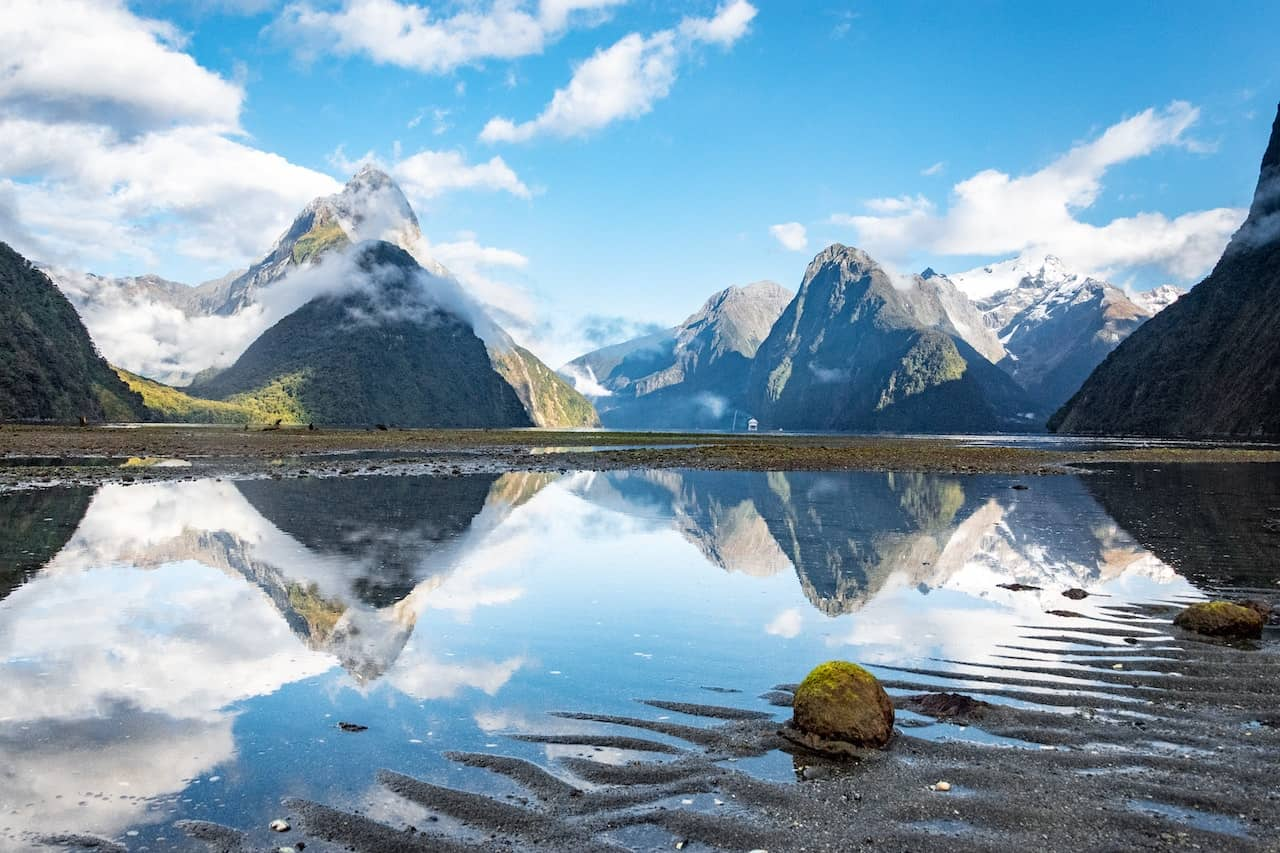How does the weather affect the scenery in Milford Sound? The weather dramatically influences the scenery here. Frequent rainfall nourishes the lush greenery and creates numerous waterfalls that cascade down the cliffs, adding dynamic elements to the landscape. Mist and fog often shroud the peaks, lending a mystical aura to the sound and enhancing its ethereal beauty. 